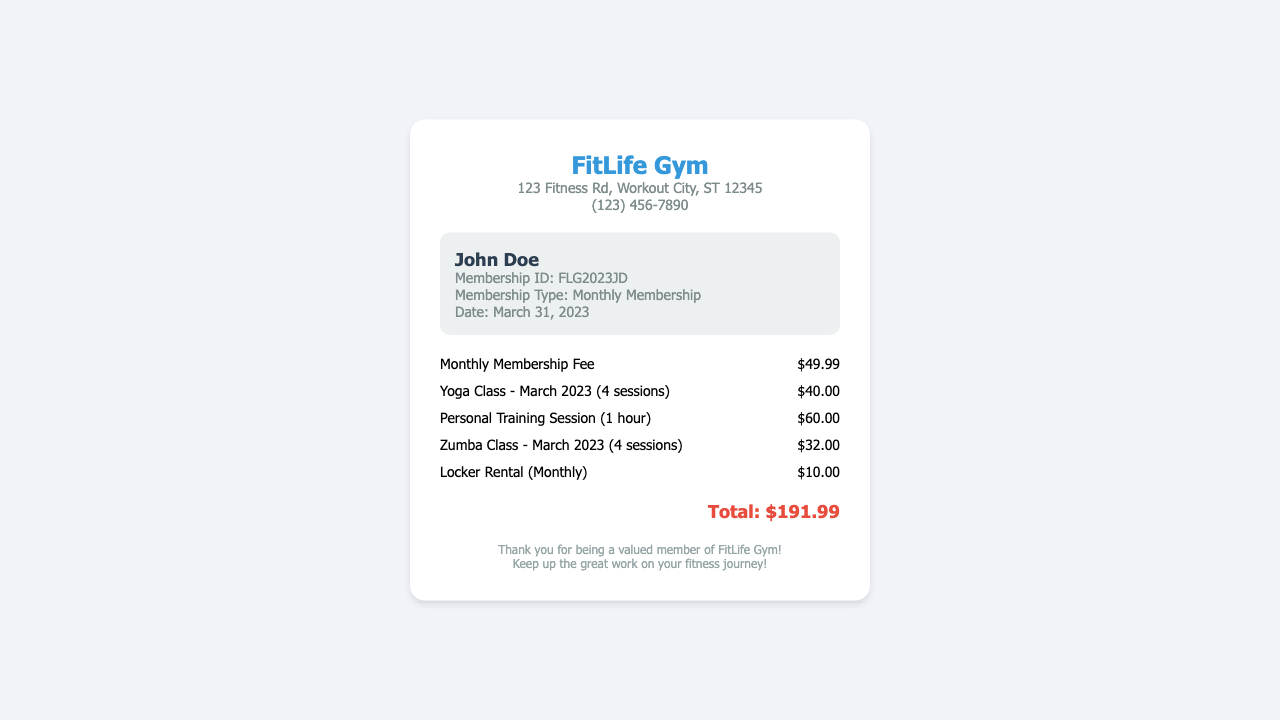What is the gym name? The gym name is displayed prominently at the top of the receipt.
Answer: FitLife Gym What is the total amount due? The total amount is calculated based on the itemized charges listed on the receipt.
Answer: $191.99 How many yoga sessions were included in March 2023? The receipt specifies the number of yoga sessions included for the month.
Answer: 4 sessions What is the membership type listed? The type of membership is mentioned in the member details section of the receipt.
Answer: Monthly Membership What date is the receipt dated? The date is included in the member details section of the receipt.
Answer: March 31, 2023 How much was charged for personal training sessions? The receipt clearly states the charge for personal training sessions.
Answer: $60.00 What is included in the charges for March besides classes? This question requires looking at other charges listed in addition to the classes.
Answer: Locker Rental What is the address of FitLife Gym? The address is listed under the gym info section.
Answer: 123 Fitness Rd, Workout City, ST 12345 How much was charged for the Zumba class? The Zumba class cost is listed in the itemized charges.
Answer: $32.00 